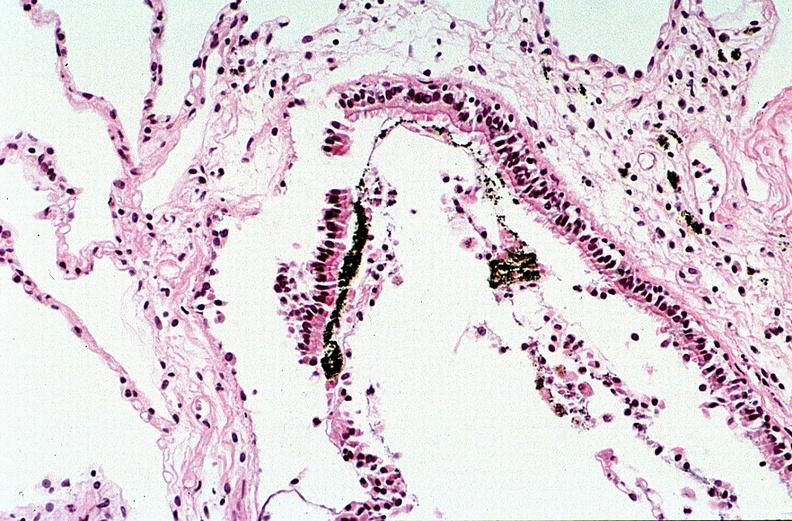what burn?
Answer the question using a single word or phrase. Thermal 